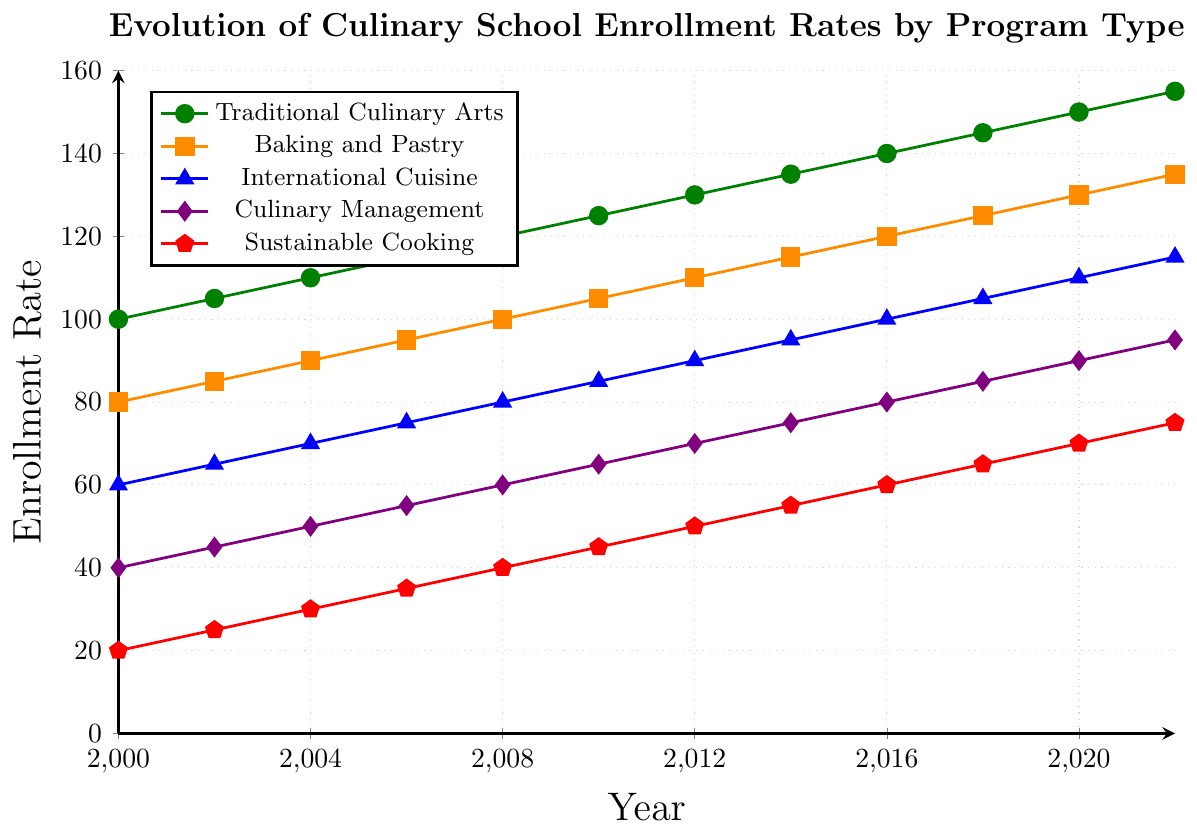What's the enrollment rate for Baking and Pastry in 2020? To find the enrollment rate for Baking and Pastry in 2020, look at the data point for Baking and Pastry on the x-axis at 2020. The y-axis value at this point is 130.
Answer: 130 Which program had the lowest enrollment rate in 2000? Identify the smallest y-axis value in the year 2000 across all programs. Traditional Culinary Arts had 100, Baking and Pastry had 80, International Cuisine had 60, Culinary Management had 40, and Sustainable Cooking had 20. The lowest value is 20 for Sustainable Cooking.
Answer: Sustainable Cooking What is the difference in enrollment rates between Traditional Culinary Arts and Culinary Management in 2012? Find the y-axis values for Traditional Culinary Arts and Culinary Management in 2012. For Traditional Culinary Arts, it is 130 and for Culinary Management, it is 70. The difference is 130 - 70 = 60.
Answer: 60 By how much has the enrollment rate for Sustainable Cooking increased from 2000 to 2022? Look at the y-axis value for Sustainable Cooking in 2000 and 2022. In 2000, it is 20, and in 2022, it is 75. The increase is 75 - 20 = 55.
Answer: 55 Which year marks the point where Baking and Pastry enrollment exceeds International Cuisine enrollment by 20 or more? Compare the y-axis values for Baking and Pastry and International Cuisine in each year to find when their difference is 20 or more. In 2000, it's 80 vs. 60 (20), and then every subsequent year increases by 20, starting from 2002 onward.
Answer: 2000 Is there any year where Culinary Management enrollment equals International Cuisine enrollment? Examine the y-axis values for Culinary Management and International Cuisine across all years to check for any equal points. There are no years where their values are equal in the given range.
Answer: No In which year did Traditional Culinary Arts enrollment first reach 140? Observe the x-axis value (year) where Traditional Culinary Arts reaches 140 on the y-axis. This happens first in 2016.
Answer: 2016 Calculate the average enrollment rate for Sustainable Cooking over the provided years. Add all y-axis values for Sustainable Cooking: 20, 25, 30, 35, 40, 45, 50, 55, 60, 65, 70, 75. Sum is 570. Divide by the number of years (12), resulting in 570 / 12 = 47.5.
Answer: 47.5 Which program shows consistent linear growth without any dips from 2000 to 2022? Examine the trend lines of each program and identify the one that has a consistent upward slope without any dips. All programs show consistent linear growth without dips.
Answer: All programs 